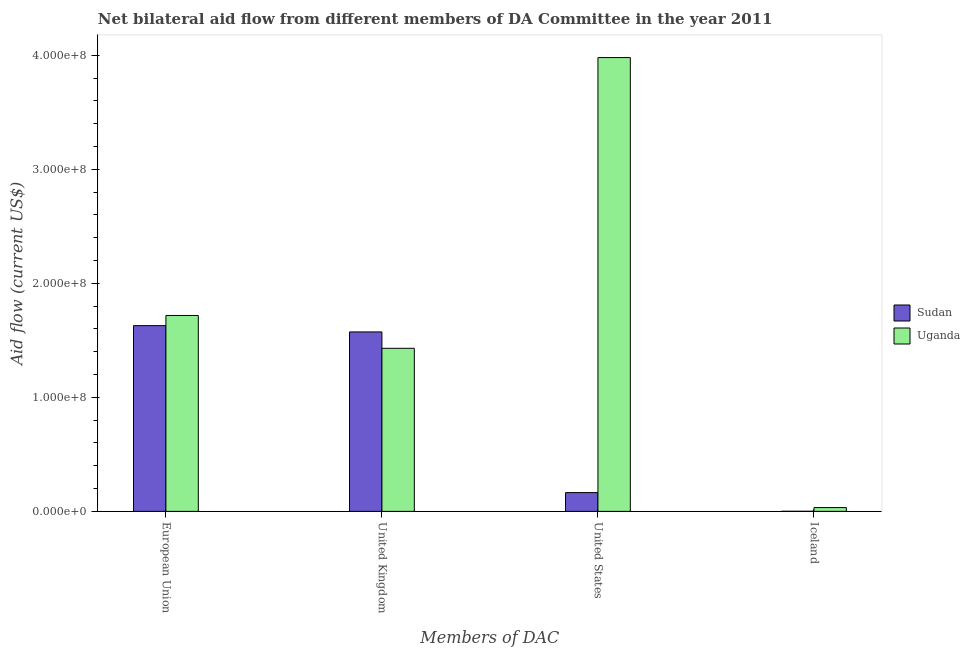How many different coloured bars are there?
Make the answer very short. 2. How many groups of bars are there?
Your answer should be compact. 4. Are the number of bars per tick equal to the number of legend labels?
Make the answer very short. Yes. Are the number of bars on each tick of the X-axis equal?
Provide a short and direct response. Yes. What is the amount of aid given by iceland in Uganda?
Your response must be concise. 3.32e+06. Across all countries, what is the maximum amount of aid given by eu?
Your answer should be compact. 1.72e+08. Across all countries, what is the minimum amount of aid given by uk?
Your response must be concise. 1.43e+08. In which country was the amount of aid given by uk maximum?
Your response must be concise. Sudan. In which country was the amount of aid given by uk minimum?
Your answer should be very brief. Uganda. What is the total amount of aid given by uk in the graph?
Ensure brevity in your answer.  3.00e+08. What is the difference between the amount of aid given by iceland in Sudan and that in Uganda?
Make the answer very short. -3.26e+06. What is the difference between the amount of aid given by iceland in Uganda and the amount of aid given by us in Sudan?
Give a very brief answer. -1.31e+07. What is the average amount of aid given by iceland per country?
Your answer should be very brief. 1.69e+06. What is the difference between the amount of aid given by eu and amount of aid given by iceland in Sudan?
Provide a succinct answer. 1.63e+08. What is the ratio of the amount of aid given by us in Uganda to that in Sudan?
Offer a very short reply. 24.19. Is the difference between the amount of aid given by eu in Uganda and Sudan greater than the difference between the amount of aid given by iceland in Uganda and Sudan?
Your answer should be compact. Yes. What is the difference between the highest and the second highest amount of aid given by eu?
Provide a succinct answer. 8.90e+06. What is the difference between the highest and the lowest amount of aid given by us?
Give a very brief answer. 3.81e+08. In how many countries, is the amount of aid given by us greater than the average amount of aid given by us taken over all countries?
Make the answer very short. 1. Is the sum of the amount of aid given by us in Uganda and Sudan greater than the maximum amount of aid given by uk across all countries?
Offer a very short reply. Yes. What does the 1st bar from the left in European Union represents?
Your answer should be very brief. Sudan. What does the 1st bar from the right in United Kingdom represents?
Your answer should be very brief. Uganda. Are all the bars in the graph horizontal?
Your answer should be very brief. No. How many countries are there in the graph?
Offer a very short reply. 2. Does the graph contain grids?
Keep it short and to the point. No. How are the legend labels stacked?
Make the answer very short. Vertical. What is the title of the graph?
Your answer should be compact. Net bilateral aid flow from different members of DA Committee in the year 2011. What is the label or title of the X-axis?
Provide a short and direct response. Members of DAC. What is the Aid flow (current US$) of Sudan in European Union?
Your answer should be compact. 1.63e+08. What is the Aid flow (current US$) in Uganda in European Union?
Your response must be concise. 1.72e+08. What is the Aid flow (current US$) in Sudan in United Kingdom?
Your answer should be very brief. 1.57e+08. What is the Aid flow (current US$) in Uganda in United Kingdom?
Your answer should be very brief. 1.43e+08. What is the Aid flow (current US$) in Sudan in United States?
Give a very brief answer. 1.64e+07. What is the Aid flow (current US$) of Uganda in United States?
Your answer should be very brief. 3.98e+08. What is the Aid flow (current US$) of Sudan in Iceland?
Provide a succinct answer. 6.00e+04. What is the Aid flow (current US$) of Uganda in Iceland?
Make the answer very short. 3.32e+06. Across all Members of DAC, what is the maximum Aid flow (current US$) in Sudan?
Your answer should be very brief. 1.63e+08. Across all Members of DAC, what is the maximum Aid flow (current US$) in Uganda?
Provide a short and direct response. 3.98e+08. Across all Members of DAC, what is the minimum Aid flow (current US$) of Sudan?
Your answer should be very brief. 6.00e+04. Across all Members of DAC, what is the minimum Aid flow (current US$) of Uganda?
Your response must be concise. 3.32e+06. What is the total Aid flow (current US$) of Sudan in the graph?
Make the answer very short. 3.37e+08. What is the total Aid flow (current US$) of Uganda in the graph?
Your response must be concise. 7.16e+08. What is the difference between the Aid flow (current US$) of Sudan in European Union and that in United Kingdom?
Give a very brief answer. 5.52e+06. What is the difference between the Aid flow (current US$) of Uganda in European Union and that in United Kingdom?
Provide a short and direct response. 2.88e+07. What is the difference between the Aid flow (current US$) of Sudan in European Union and that in United States?
Provide a short and direct response. 1.46e+08. What is the difference between the Aid flow (current US$) in Uganda in European Union and that in United States?
Offer a terse response. -2.26e+08. What is the difference between the Aid flow (current US$) of Sudan in European Union and that in Iceland?
Offer a very short reply. 1.63e+08. What is the difference between the Aid flow (current US$) of Uganda in European Union and that in Iceland?
Offer a terse response. 1.68e+08. What is the difference between the Aid flow (current US$) in Sudan in United Kingdom and that in United States?
Provide a succinct answer. 1.41e+08. What is the difference between the Aid flow (current US$) of Uganda in United Kingdom and that in United States?
Offer a very short reply. -2.55e+08. What is the difference between the Aid flow (current US$) of Sudan in United Kingdom and that in Iceland?
Provide a short and direct response. 1.57e+08. What is the difference between the Aid flow (current US$) of Uganda in United Kingdom and that in Iceland?
Keep it short and to the point. 1.40e+08. What is the difference between the Aid flow (current US$) of Sudan in United States and that in Iceland?
Provide a succinct answer. 1.64e+07. What is the difference between the Aid flow (current US$) in Uganda in United States and that in Iceland?
Your answer should be compact. 3.95e+08. What is the difference between the Aid flow (current US$) of Sudan in European Union and the Aid flow (current US$) of Uganda in United Kingdom?
Provide a succinct answer. 1.99e+07. What is the difference between the Aid flow (current US$) of Sudan in European Union and the Aid flow (current US$) of Uganda in United States?
Give a very brief answer. -2.35e+08. What is the difference between the Aid flow (current US$) in Sudan in European Union and the Aid flow (current US$) in Uganda in Iceland?
Provide a succinct answer. 1.60e+08. What is the difference between the Aid flow (current US$) of Sudan in United Kingdom and the Aid flow (current US$) of Uganda in United States?
Your answer should be compact. -2.41e+08. What is the difference between the Aid flow (current US$) of Sudan in United Kingdom and the Aid flow (current US$) of Uganda in Iceland?
Your response must be concise. 1.54e+08. What is the difference between the Aid flow (current US$) of Sudan in United States and the Aid flow (current US$) of Uganda in Iceland?
Provide a short and direct response. 1.31e+07. What is the average Aid flow (current US$) in Sudan per Members of DAC?
Your response must be concise. 8.42e+07. What is the average Aid flow (current US$) in Uganda per Members of DAC?
Keep it short and to the point. 1.79e+08. What is the difference between the Aid flow (current US$) of Sudan and Aid flow (current US$) of Uganda in European Union?
Provide a short and direct response. -8.90e+06. What is the difference between the Aid flow (current US$) of Sudan and Aid flow (current US$) of Uganda in United Kingdom?
Give a very brief answer. 1.44e+07. What is the difference between the Aid flow (current US$) in Sudan and Aid flow (current US$) in Uganda in United States?
Make the answer very short. -3.81e+08. What is the difference between the Aid flow (current US$) of Sudan and Aid flow (current US$) of Uganda in Iceland?
Your answer should be compact. -3.26e+06. What is the ratio of the Aid flow (current US$) in Sudan in European Union to that in United Kingdom?
Give a very brief answer. 1.04. What is the ratio of the Aid flow (current US$) of Uganda in European Union to that in United Kingdom?
Provide a short and direct response. 1.2. What is the ratio of the Aid flow (current US$) in Sudan in European Union to that in United States?
Your answer should be compact. 9.9. What is the ratio of the Aid flow (current US$) of Uganda in European Union to that in United States?
Your response must be concise. 0.43. What is the ratio of the Aid flow (current US$) in Sudan in European Union to that in Iceland?
Your response must be concise. 2714.33. What is the ratio of the Aid flow (current US$) of Uganda in European Union to that in Iceland?
Your answer should be very brief. 51.73. What is the ratio of the Aid flow (current US$) in Sudan in United Kingdom to that in United States?
Offer a very short reply. 9.56. What is the ratio of the Aid flow (current US$) of Uganda in United Kingdom to that in United States?
Provide a short and direct response. 0.36. What is the ratio of the Aid flow (current US$) in Sudan in United Kingdom to that in Iceland?
Provide a short and direct response. 2622.33. What is the ratio of the Aid flow (current US$) in Uganda in United Kingdom to that in Iceland?
Ensure brevity in your answer.  43.07. What is the ratio of the Aid flow (current US$) of Sudan in United States to that in Iceland?
Offer a very short reply. 274.17. What is the ratio of the Aid flow (current US$) in Uganda in United States to that in Iceland?
Offer a very short reply. 119.86. What is the difference between the highest and the second highest Aid flow (current US$) in Sudan?
Your response must be concise. 5.52e+06. What is the difference between the highest and the second highest Aid flow (current US$) in Uganda?
Your answer should be compact. 2.26e+08. What is the difference between the highest and the lowest Aid flow (current US$) of Sudan?
Make the answer very short. 1.63e+08. What is the difference between the highest and the lowest Aid flow (current US$) of Uganda?
Offer a very short reply. 3.95e+08. 